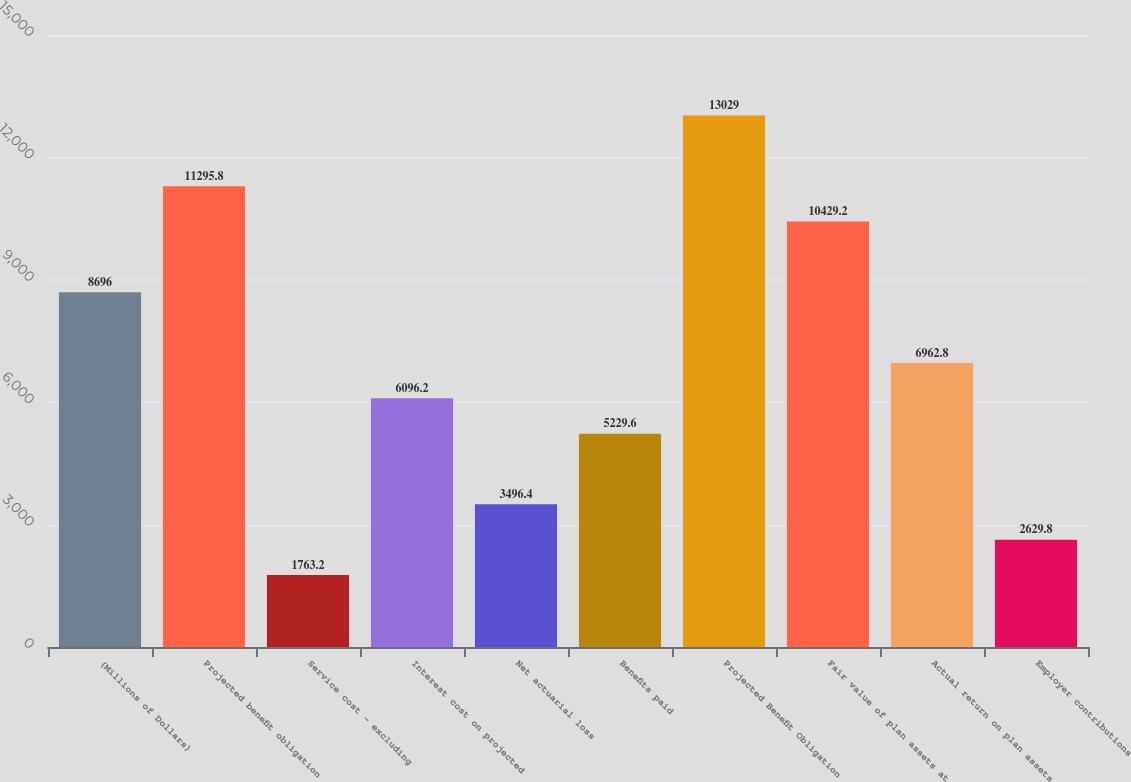Convert chart. <chart><loc_0><loc_0><loc_500><loc_500><bar_chart><fcel>(Millions of Dollars)<fcel>Projected benefit obligation<fcel>Service cost - excluding<fcel>Interest cost on projected<fcel>Net actuarial loss<fcel>Benefits paid<fcel>Projected Benefit Obligation<fcel>Fair value of plan assets at<fcel>Actual return on plan assets<fcel>Employer contributions<nl><fcel>8696<fcel>11295.8<fcel>1763.2<fcel>6096.2<fcel>3496.4<fcel>5229.6<fcel>13029<fcel>10429.2<fcel>6962.8<fcel>2629.8<nl></chart> 